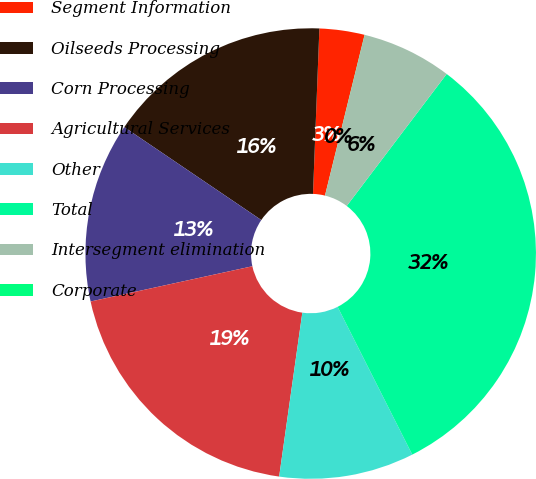Convert chart. <chart><loc_0><loc_0><loc_500><loc_500><pie_chart><fcel>Segment Information<fcel>Oilseeds Processing<fcel>Corn Processing<fcel>Agricultural Services<fcel>Other<fcel>Total<fcel>Intersegment elimination<fcel>Corporate<nl><fcel>3.23%<fcel>16.13%<fcel>12.9%<fcel>19.35%<fcel>9.68%<fcel>32.24%<fcel>6.46%<fcel>0.01%<nl></chart> 